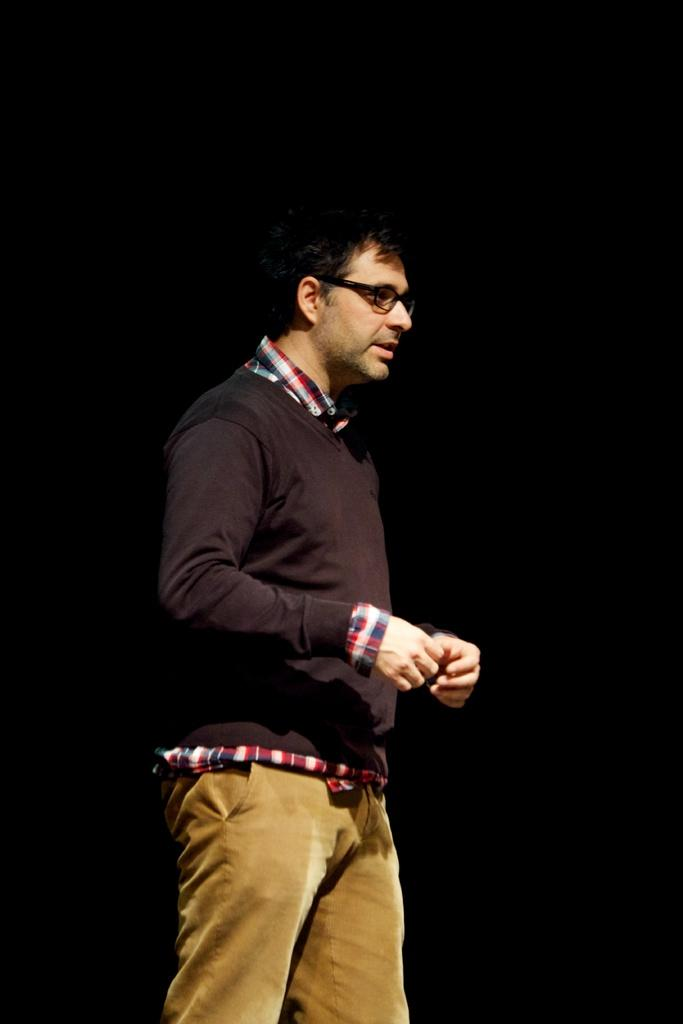What is the main subject of the image? There is a person in the image. What is the person doing in the image? The person is standing. What color is the shirt the person is wearing? The person is wearing a black shirt. What color are the pants the person is wearing? The person is wearing brown pants. What can be observed about the background of the image? The background of the image is dark. What type of leather is used to make the caption in the image? There is no caption present in the image, and therefore no leather can be associated with it. 